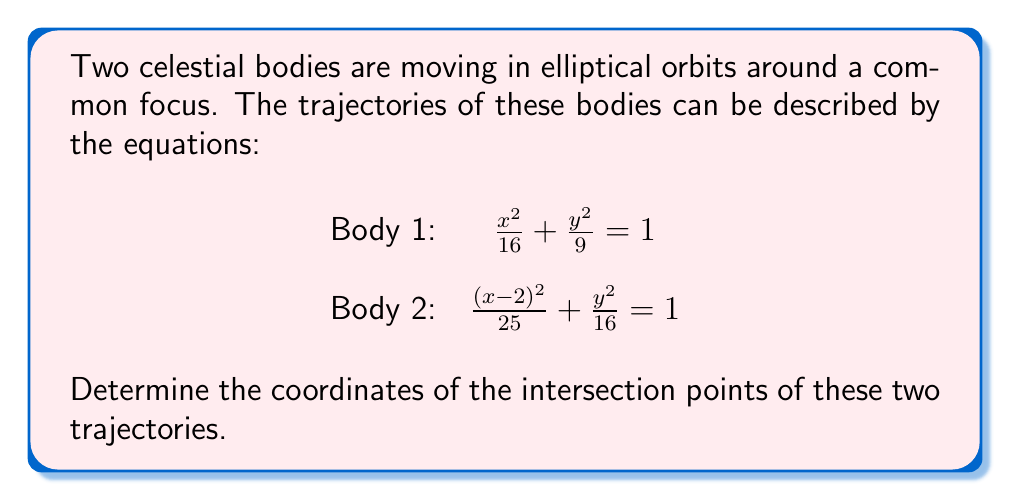Give your solution to this math problem. To find the intersection points of these two elliptical trajectories, we need to solve the system of equations:

$$\begin{cases}
\frac{x^2}{16} + \frac{y^2}{9} = 1 \\
\frac{(x-2)^2}{25} + \frac{y^2}{16} = 1
\end{cases}$$

Step 1: Rearrange the first equation to isolate $y^2$:
$$y^2 = 9 - \frac{9x^2}{16}$$

Step 2: Substitute this expression for $y^2$ into the second equation:
$$\frac{(x-2)^2}{25} + \frac{9 - \frac{9x^2}{16}}{16} = 1$$

Step 3: Multiply both sides by 400 to eliminate fractions:
$$16(x-2)^2 + 25(9 - \frac{9x^2}{16}) = 400$$

Step 4: Expand and simplify:
$$16x^2 - 64x + 64 + 225 - \frac{225x^2}{16} = 400$$
$$16x^2 - 64x - \frac{225x^2}{16} + 289 = 400$$
$$256x^2 - 1024x - 225x^2 + 4624 = 6400$$
$$31x^2 - 1024x - 1776 = 0$$

Step 5: Solve this quadratic equation using the quadratic formula:
$$x = \frac{1024 \pm \sqrt{1024^2 + 4(31)(1776)}}{2(31)}$$

Step 6: Calculate the x-coordinates:
$$x \approx 3.8656 \text{ or } x \approx -1.8656$$

Step 7: Substitute these x-values back into the original equation for Body 1 to find the corresponding y-coordinates:
$$y^2 = 9 - \frac{9x^2}{16}$$

For $x \approx 3.8656$: $y \approx \pm 1.3416$
For $x \approx -1.8656$: $y \approx \pm 2.6584$

Therefore, the intersection points are approximately (3.8656, 1.3416), (3.8656, -1.3416), (-1.8656, 2.6584), and (-1.8656, -2.6584).
Answer: The coordinates of the intersection points are approximately:
(3.8656, 1.3416), (3.8656, -1.3416), (-1.8656, 2.6584), and (-1.8656, -2.6584). 